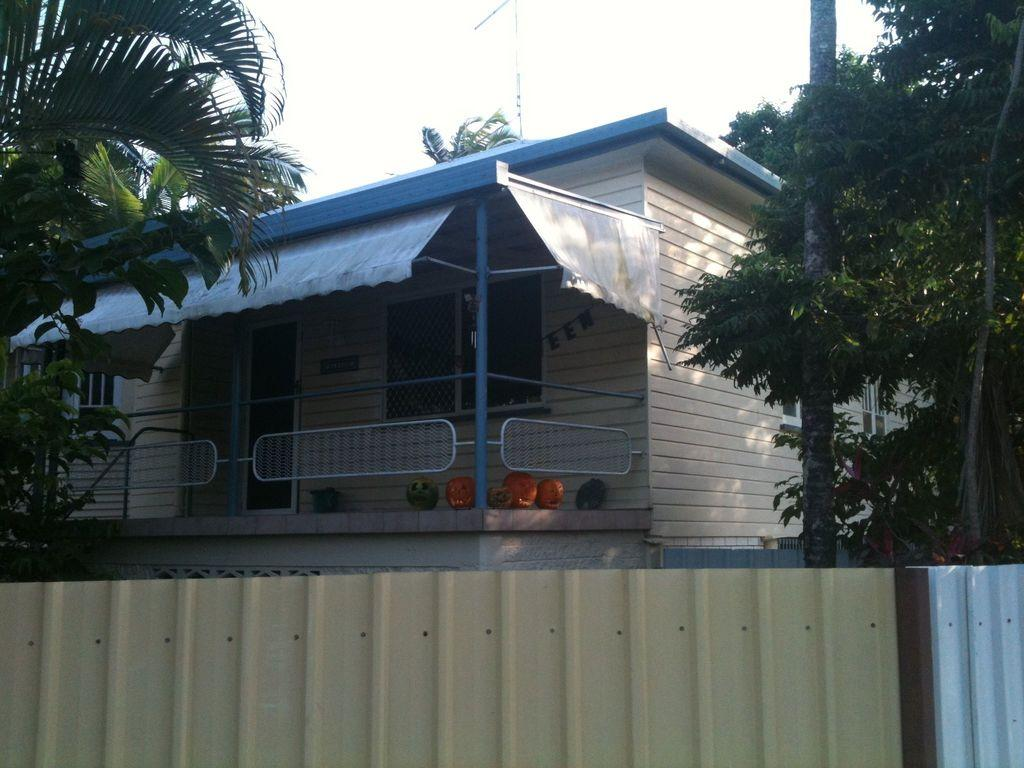What type of structure is present in the image? There is a building in the image. What feature can be seen on the building? The building has windows. What objects are present in the image besides the building? There are pumpkins and trees in the image. What other architectural element is visible in the image? There is a wall in the image. What can be seen in the background of the image? The sky is visible in the background of the image. What type of badge is being awarded to the person in the image? There is no person or badge present in the image; it features a building, pumpkins, trees, a wall, and the sky. What fictional character is depicted in the image? The image does not depict any fictional characters; it features a building, pumpkins, trees, a wall, and the sky. 